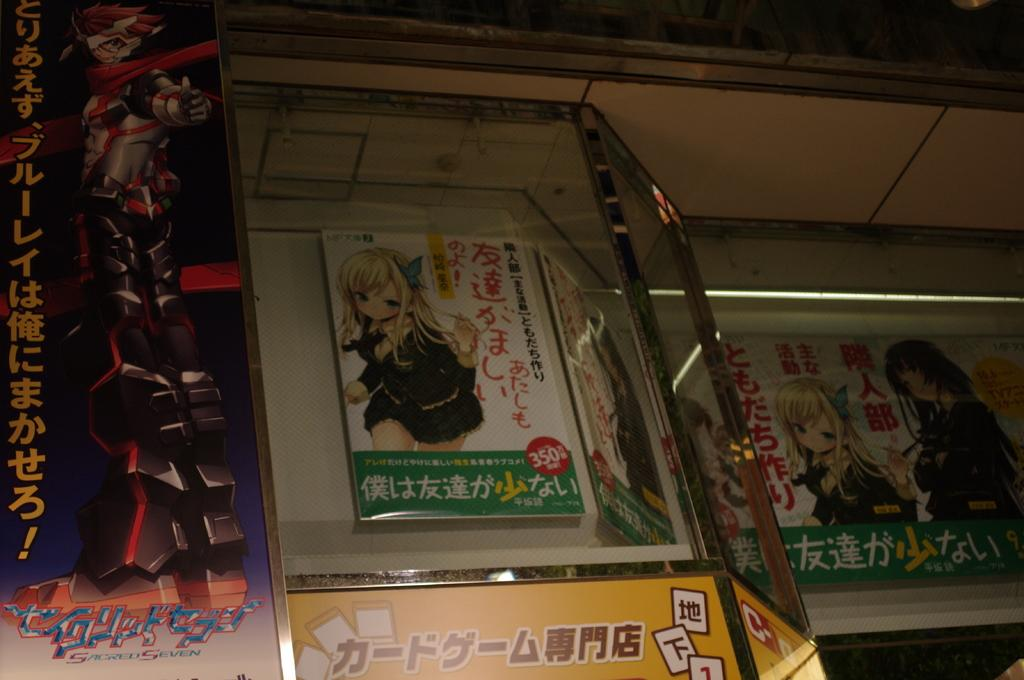What can be seen on the poster in the image? The poster contains an animated image of a girl wearing clothes. What is the material of the window in the image? The window in the image is made of glass. What else is present on the poster besides the animated image? There is text on the poster. Can you tell me how many cars are parked outside the window in the image? There is no information about cars or parking in the image; it only shows a poster and a glass window. Is there a boy featured in the animated image on the poster? No, the animated image on the poster features a girl, not a boy. 